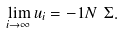<formula> <loc_0><loc_0><loc_500><loc_500>\lim _ { i \to \infty } u _ { i } = - 1 N \ \Sigma .</formula> 